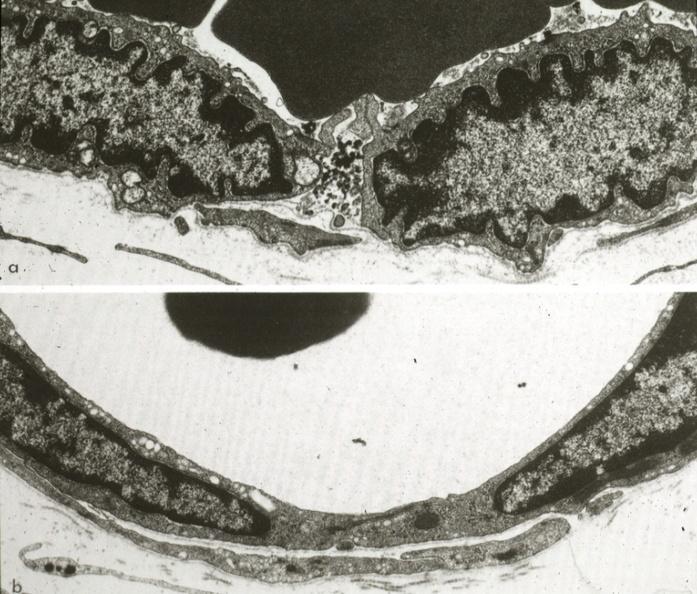s lower chest and abdomen anterior present?
Answer the question using a single word or phrase. No 